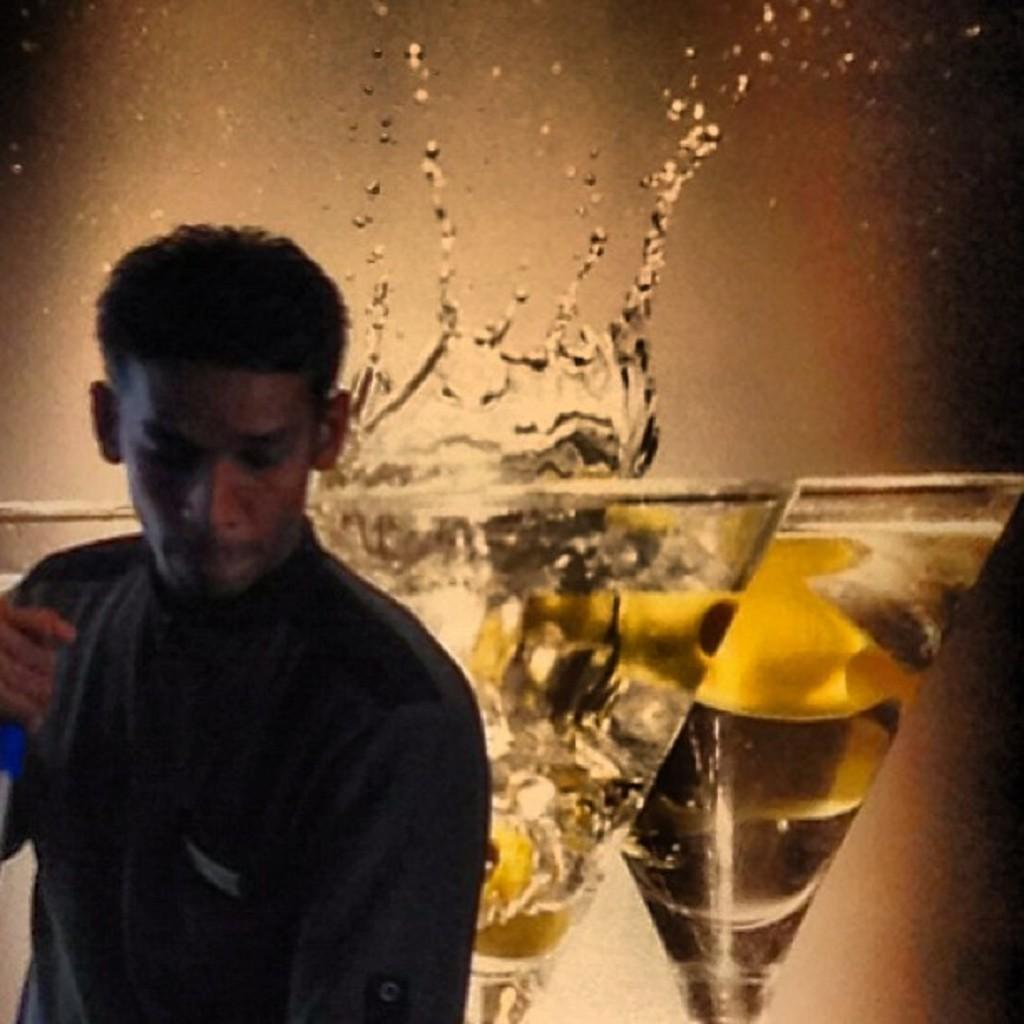What is the man in the image doing? The man is standing in the image. What is the man holding in the image? The man is holding an object. What can be seen in the glasses in the image? There is a drink in the glasses. What type of coal is visible in the image? There is no coal present in the image. How many bikes can be seen in the image? There is no bike present in the image. 